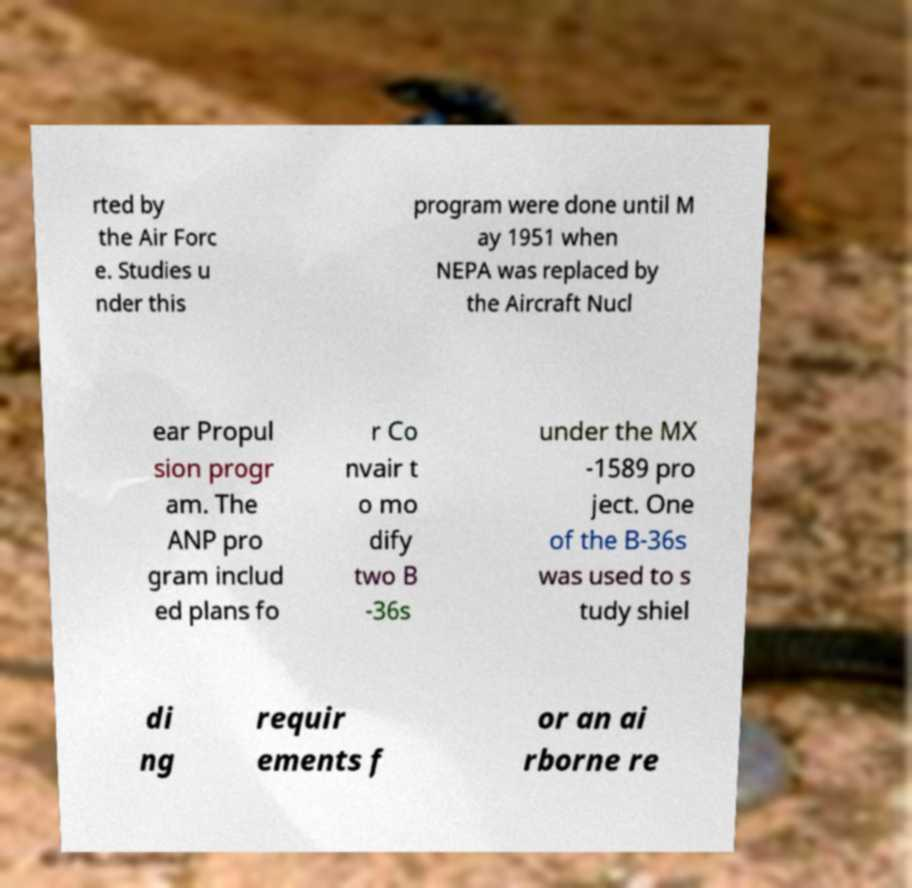I need the written content from this picture converted into text. Can you do that? rted by the Air Forc e. Studies u nder this program were done until M ay 1951 when NEPA was replaced by the Aircraft Nucl ear Propul sion progr am. The ANP pro gram includ ed plans fo r Co nvair t o mo dify two B -36s under the MX -1589 pro ject. One of the B-36s was used to s tudy shiel di ng requir ements f or an ai rborne re 